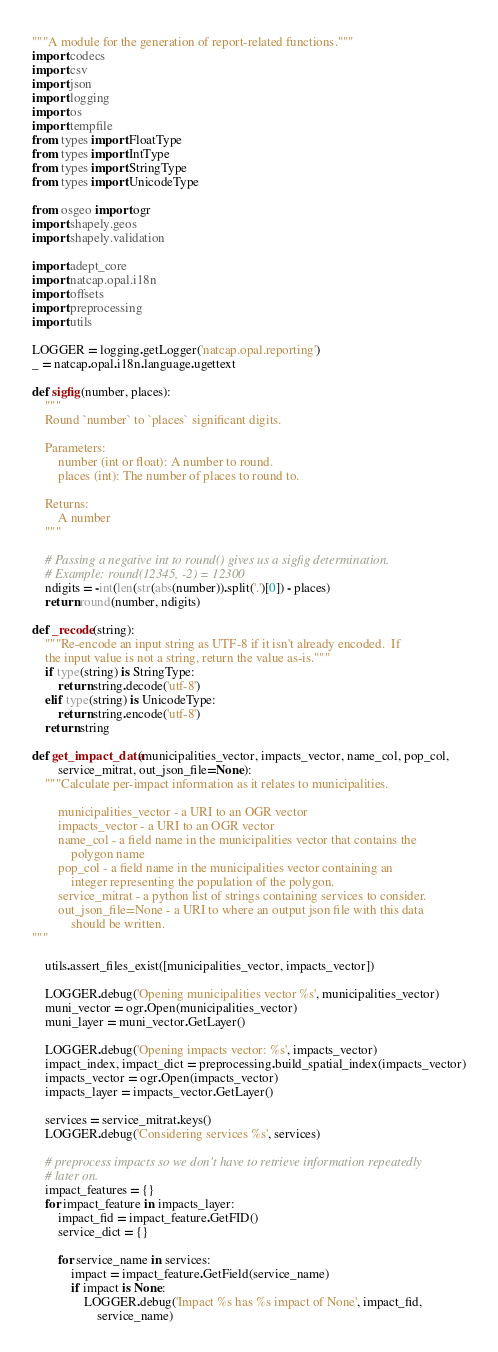Convert code to text. <code><loc_0><loc_0><loc_500><loc_500><_Python_>"""A module for the generation of report-related functions."""
import codecs
import csv
import json
import logging
import os
import tempfile
from types import FloatType
from types import IntType
from types import StringType
from types import UnicodeType

from osgeo import ogr
import shapely.geos
import shapely.validation

import adept_core
import natcap.opal.i18n
import offsets
import preprocessing
import utils

LOGGER = logging.getLogger('natcap.opal.reporting')
_ = natcap.opal.i18n.language.ugettext

def sigfig(number, places):
    """
    Round `number` to `places` significant digits.

    Parameters:
        number (int or float): A number to round.
        places (int): The number of places to round to.

    Returns:
        A number
    """

    # Passing a negative int to round() gives us a sigfig determination.
    # Example: round(12345, -2) = 12300
    ndigits = -int(len(str(abs(number)).split('.')[0]) - places)
    return round(number, ndigits)

def _recode(string):
    """Re-encode an input string as UTF-8 if it isn't already encoded.  If
    the input value is not a string, return the value as-is."""
    if type(string) is StringType:
        return string.decode('utf-8')
    elif type(string) is UnicodeType:
        return string.encode('utf-8')
    return string

def get_impact_data(municipalities_vector, impacts_vector, name_col, pop_col,
        service_mitrat, out_json_file=None):
    """Calculate per-impact information as it relates to municipalities.

        municipalities_vector - a URI to an OGR vector
        impacts_vector - a URI to an OGR vector
        name_col - a field name in the municipalities vector that contains the
            polygon name
        pop_col - a field name in the municipalities vector containing an
            integer representing the population of the polygon.
        service_mitrat - a python list of strings containing services to consider.
        out_json_file=None - a URI to where an output json file with this data
            should be written.
"""

    utils.assert_files_exist([municipalities_vector, impacts_vector])

    LOGGER.debug('Opening municipalities vector %s', municipalities_vector)
    muni_vector = ogr.Open(municipalities_vector)
    muni_layer = muni_vector.GetLayer()

    LOGGER.debug('Opening impacts vector: %s', impacts_vector)
    impact_index, impact_dict = preprocessing.build_spatial_index(impacts_vector)
    impacts_vector = ogr.Open(impacts_vector)
    impacts_layer = impacts_vector.GetLayer()

    services = service_mitrat.keys()
    LOGGER.debug('Considering services %s', services)

    # preprocess impacts so we don't have to retrieve information repeatedly
    # later on.
    impact_features = {}
    for impact_feature in impacts_layer:
        impact_fid = impact_feature.GetFID()
        service_dict = {}

        for service_name in services:
            impact = impact_feature.GetField(service_name)
            if impact is None:
                LOGGER.debug('Impact %s has %s impact of None', impact_fid,
                    service_name)</code> 